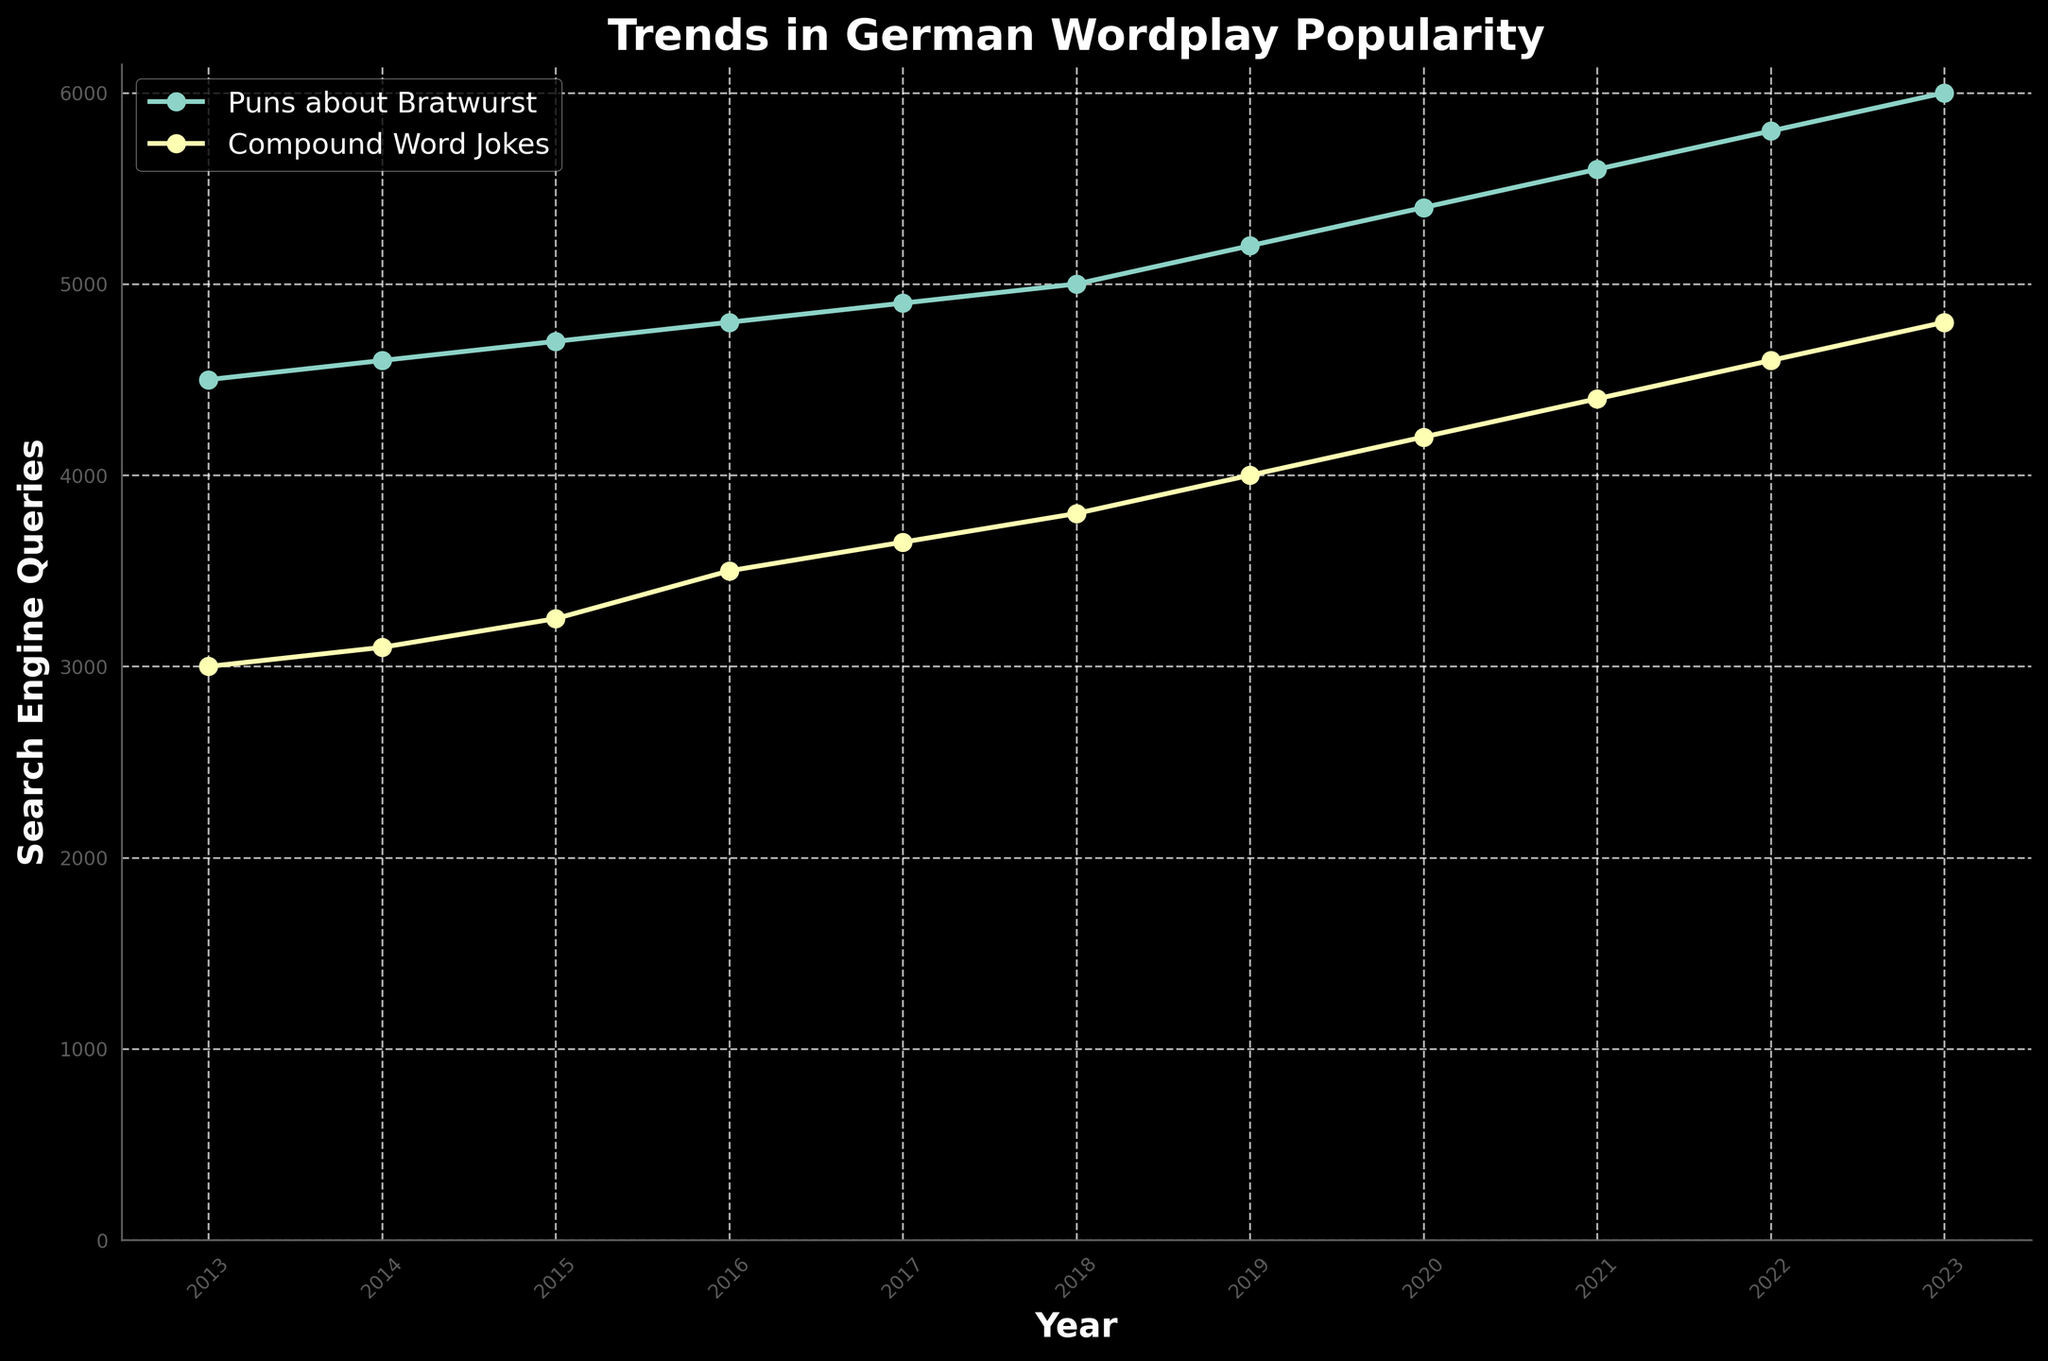What is the title of the plot? The title is displayed prominently at the top of the figure and indicates what the graph is about.
Answer: Trends in German Wordplay Popularity How many types of wordplay are shown in the plot? By identifying unique labels in the legend, we can see that two types of wordplay are represented.
Answer: Two What is the trend for "Puns about Bratwurst" in terms of search engine queries from 2013 to 2023? Follow the line labeled "Puns about Bratwurst" to see if it generally moves upward, downward, or stays flat over the years. The line trends upward.
Answer: Increasing Which type of wordplay had higher search engine queries in the year 2020? Compare the heights of the points for each wordplay type at the year 2020. The point for "Puns about Bratwurst" is higher than "Compound Word Jokes".
Answer: Puns about Bratwurst How many search engine queries were made for "Compound Word Jokes" in 2023? Locate the year 2023 on the x-axis and follow it up to the point labeled "Compound Word Jokes" to read the value on the y-axis. This point is at 4800.
Answer: 4800 By how many queries did the search engine queries for "Puns about Bratwurst" increase from 2015 to 2023? Find the values for 2015 and 2023 for "Puns about Bratwurst" (4700 and 6000). Subtract the 2015 value from the 2023 value: 6000 - 4700.
Answer: 1300 Which year saw the highest number of search engine queries for "Compound Word Jokes"? Identify which point on the line for "Compound Word Jokes" is at the maximum y-value. That point is at 2023 with a value of 4800.
Answer: 2023 What is the average number of search engine queries for "Puns about Bratwurst" in 2021 and 2022? Add the values for 2021 and 2022 for "Puns about Bratwurst" (5600 and 5800) and divide by two. The sum is 11400, and the average is 11400/2.
Answer: 5700 Compare the rates of increase in search engine queries between "Puns about Bratwurst" and "Compound Word Jokes" from 2013 to 2023. Which has a higher rate? Calculate the increase for each wordplay (Puns about Bratwurst: 6000-4500 = 1500, Compound Word Jokes: 4800-3000=1800) and compare these increases. "Compound Word Jokes" has a higher increase (1800 vs. 1500).
Answer: Compound Word Jokes 